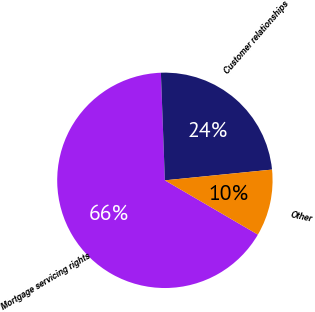Convert chart. <chart><loc_0><loc_0><loc_500><loc_500><pie_chart><fcel>Mortgage servicing rights<fcel>Customer relationships<fcel>Other<nl><fcel>66.0%<fcel>24.0%<fcel>10.0%<nl></chart> 